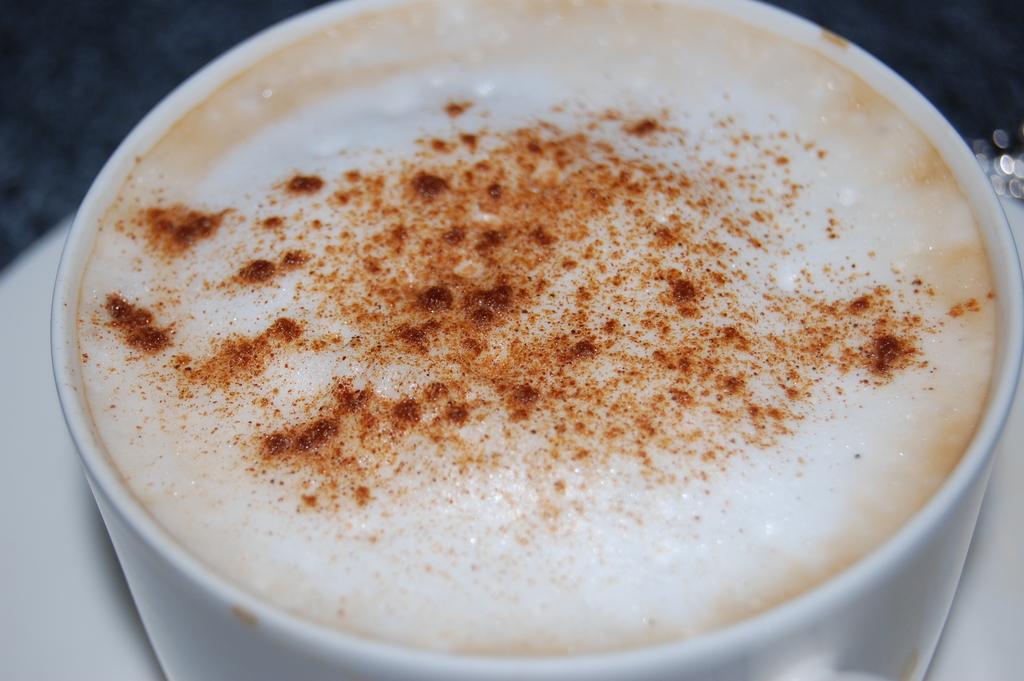Describe this image in one or two sentences. In this picture I can see there is a cup of hot beverage served and there is something sprinkled on it and there is a saucer. 